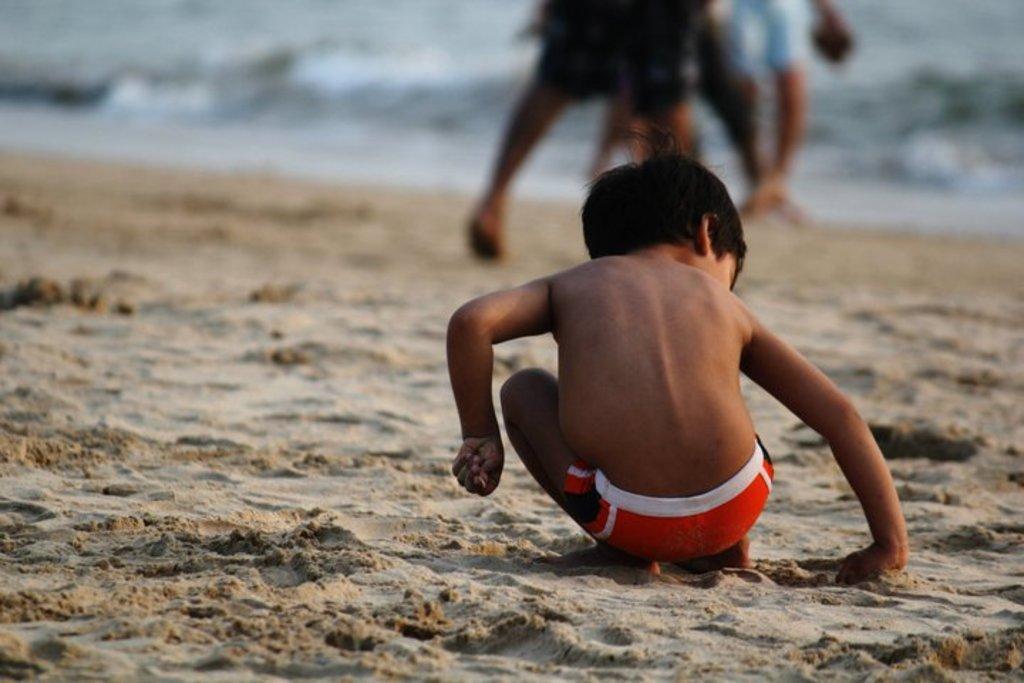How would you summarize this image in a sentence or two? In the image there is a kid sitting on the sand. In the background there are legs of people. And there is a blur background. 